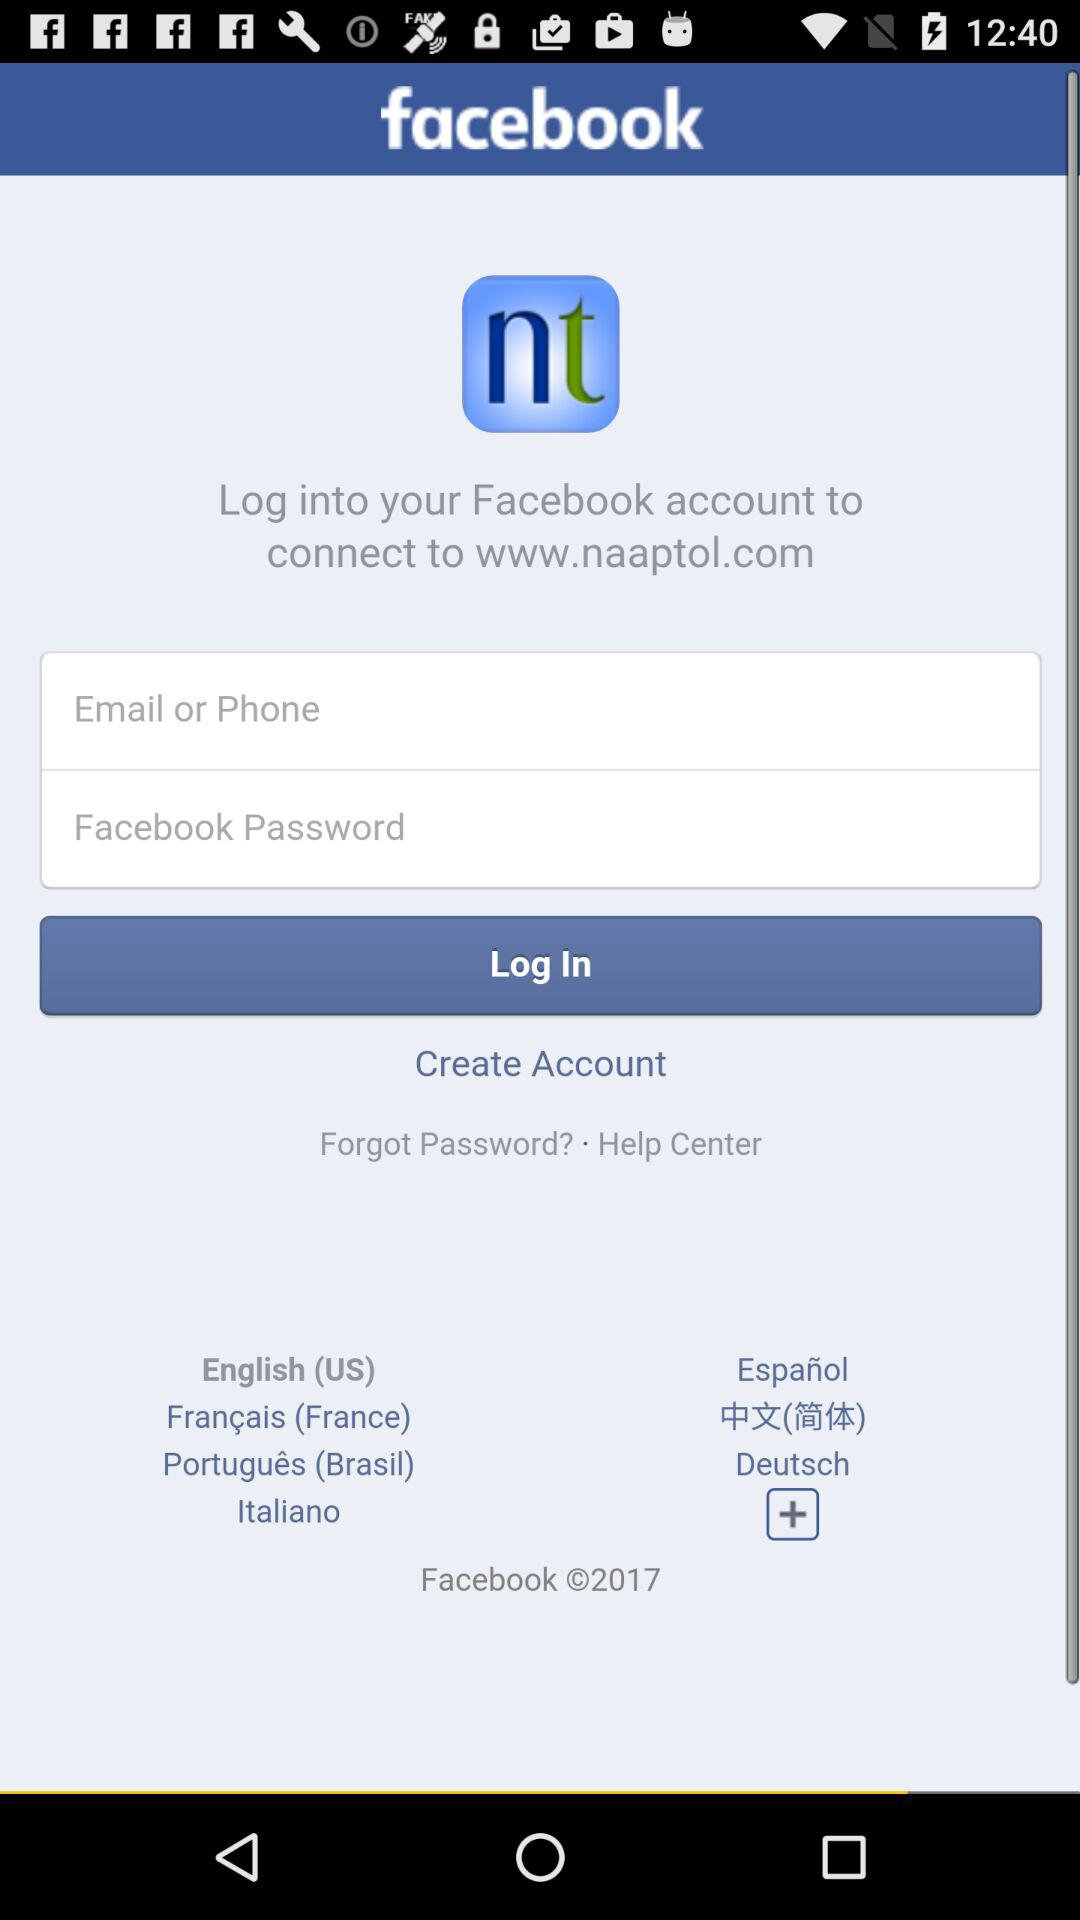How many text inputs are there for user input?
Answer the question using a single word or phrase. 2 